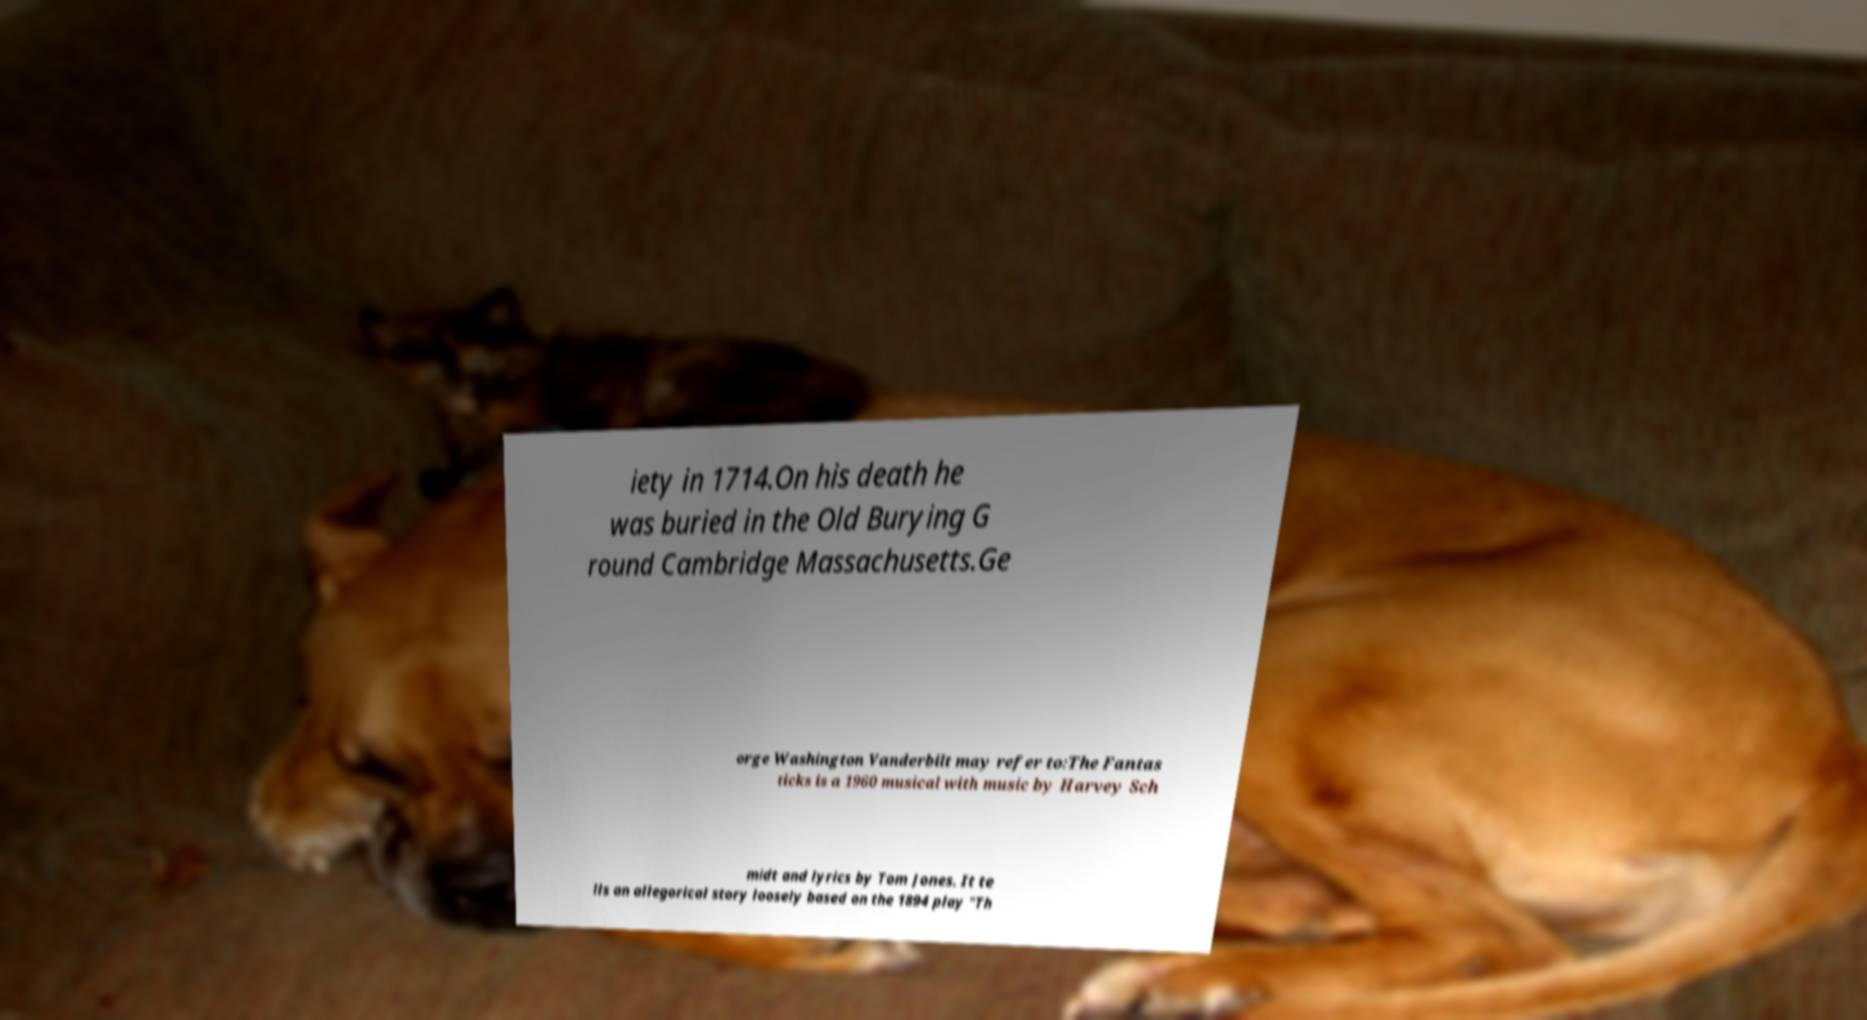Can you accurately transcribe the text from the provided image for me? iety in 1714.On his death he was buried in the Old Burying G round Cambridge Massachusetts.Ge orge Washington Vanderbilt may refer to:The Fantas ticks is a 1960 musical with music by Harvey Sch midt and lyrics by Tom Jones. It te lls an allegorical story loosely based on the 1894 play "Th 